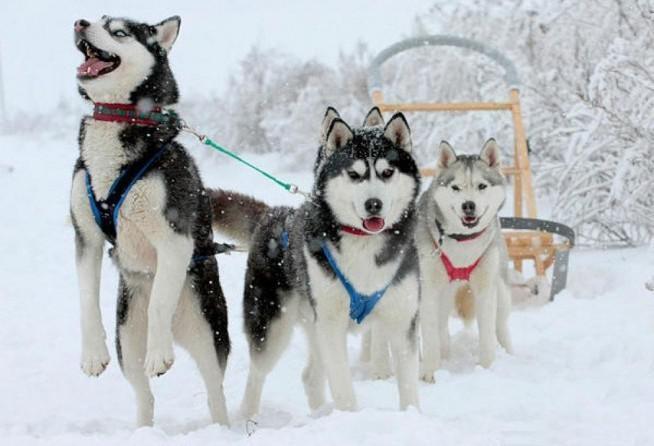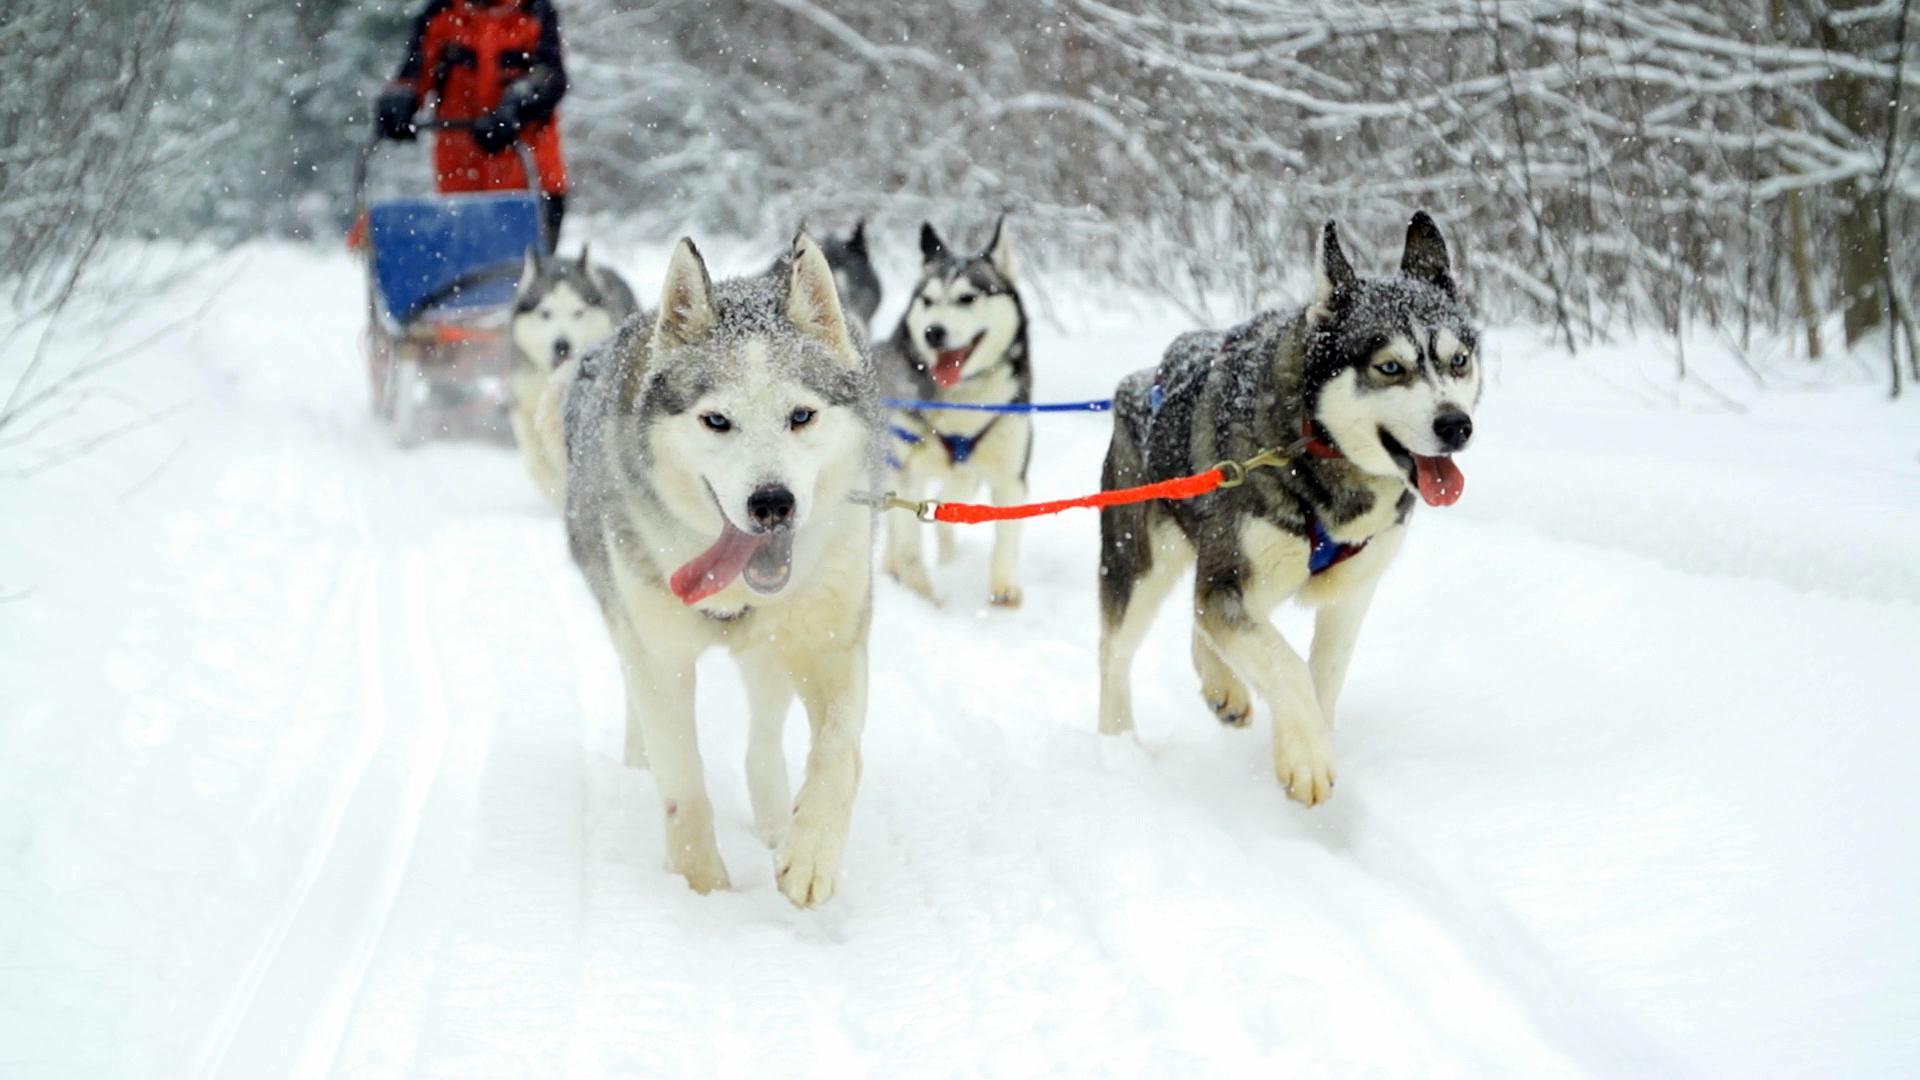The first image is the image on the left, the second image is the image on the right. Examine the images to the left and right. Is the description "The right image features multiple husky dogs with dark-and-white fur and no booties racing toward the camera with tongues hanging out." accurate? Answer yes or no. Yes. The first image is the image on the left, the second image is the image on the right. Assess this claim about the two images: "Exactly one of the lead dogs has both front paws off the ground.". Correct or not? Answer yes or no. Yes. 